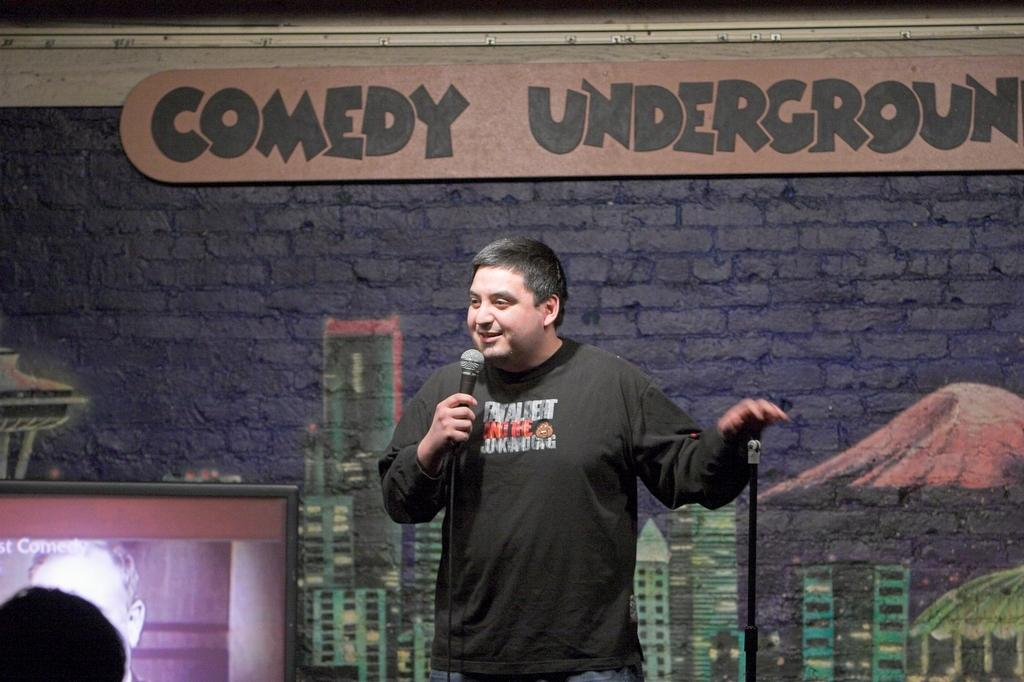What is the main subject of the image? There is a man in the image. What is the man doing in the image? The man is standing and speaking with the help of a microphone in his hand. What can be seen on the wall in the image? There is a painting and some text on the wall in the image. What electronic device is present in the image? There is a television in the image. How many wristbands is the man wearing in the image? There is no mention of wristbands in the image, so it is impossible to determine how many the man is wearing. 